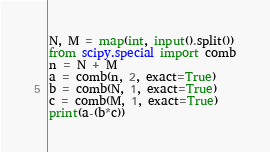Convert code to text. <code><loc_0><loc_0><loc_500><loc_500><_Python_>N, M = map(int, input().split())
from scipy.special import comb
n = N + M
a = comb(n, 2, exact=True)
b = comb(N, 1, exact=True)
c = comb(M, 1, exact=True)
print(a-(b*c))</code> 